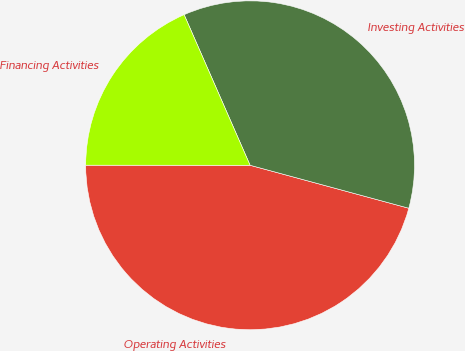Convert chart. <chart><loc_0><loc_0><loc_500><loc_500><pie_chart><fcel>Operating Activities<fcel>Investing Activities<fcel>Financing Activities<nl><fcel>45.8%<fcel>35.78%<fcel>18.42%<nl></chart> 